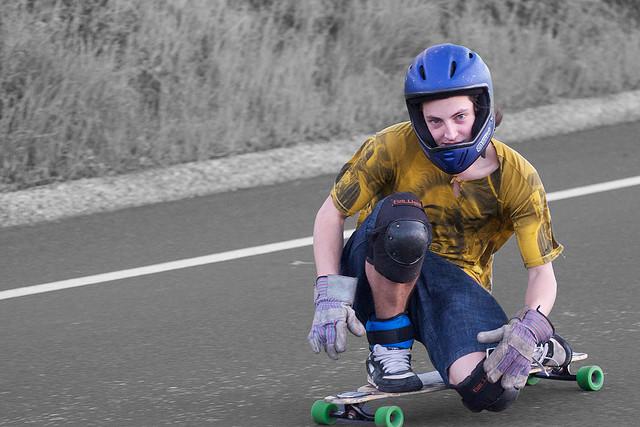What is on the man's hands?
Concise answer only. Gloves. What is he riding?
Write a very short answer. Skateboard. What color is this man's helmet?
Write a very short answer. Blue. 